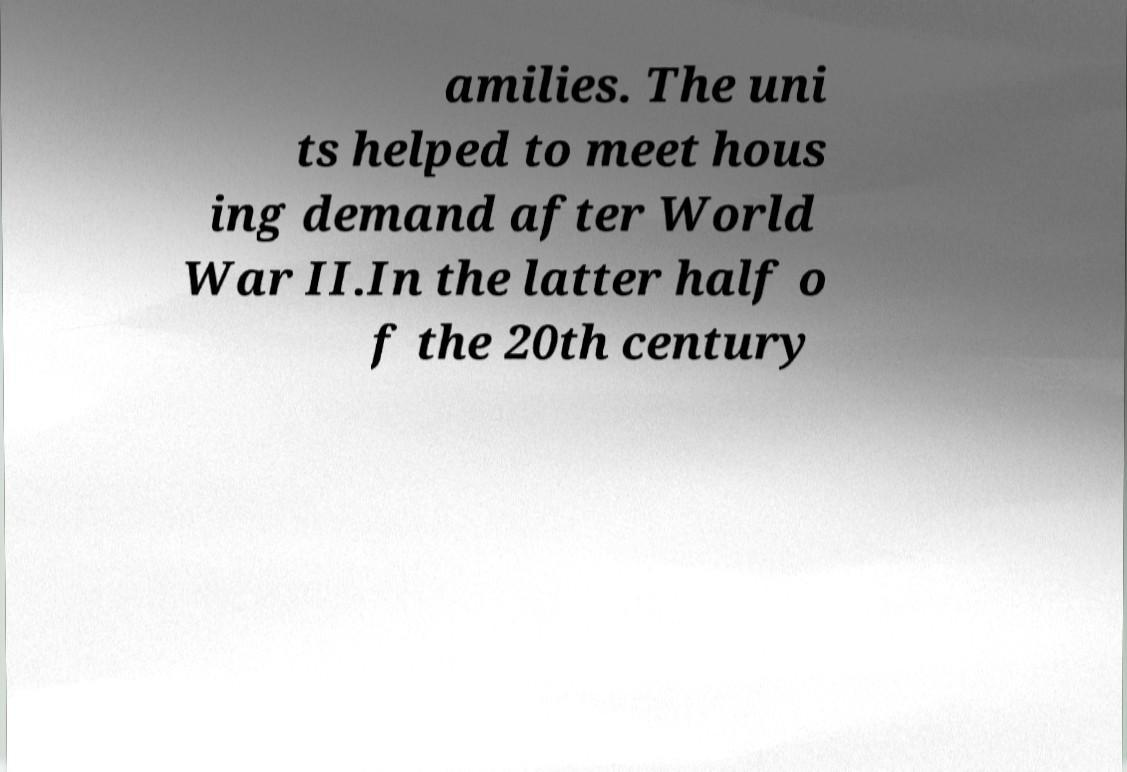Please read and relay the text visible in this image. What does it say? amilies. The uni ts helped to meet hous ing demand after World War II.In the latter half o f the 20th century 